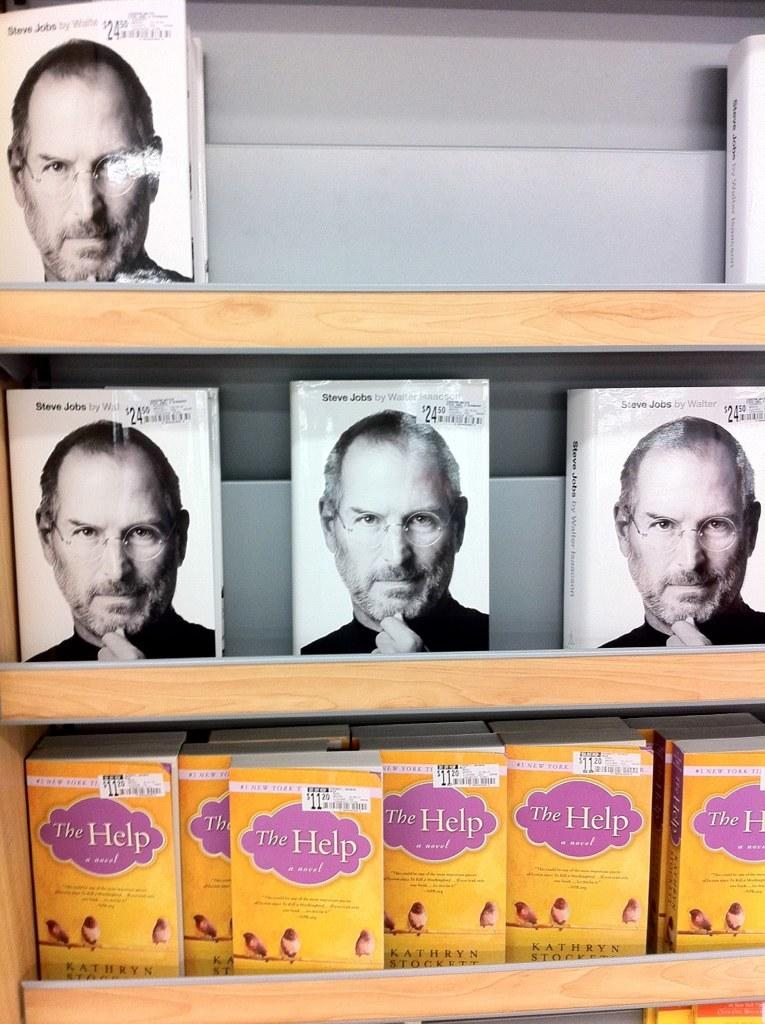What objects are visible in the image? There are books in the image. Where are the books located? The books are in a shelf. Can you describe the setting in which the image was taken? The image may have been taken in a shop, but this cannot be confirmed without additional context or information. What type of jewel is the actor wearing in the image? There is no actor or jewel present in the image. 